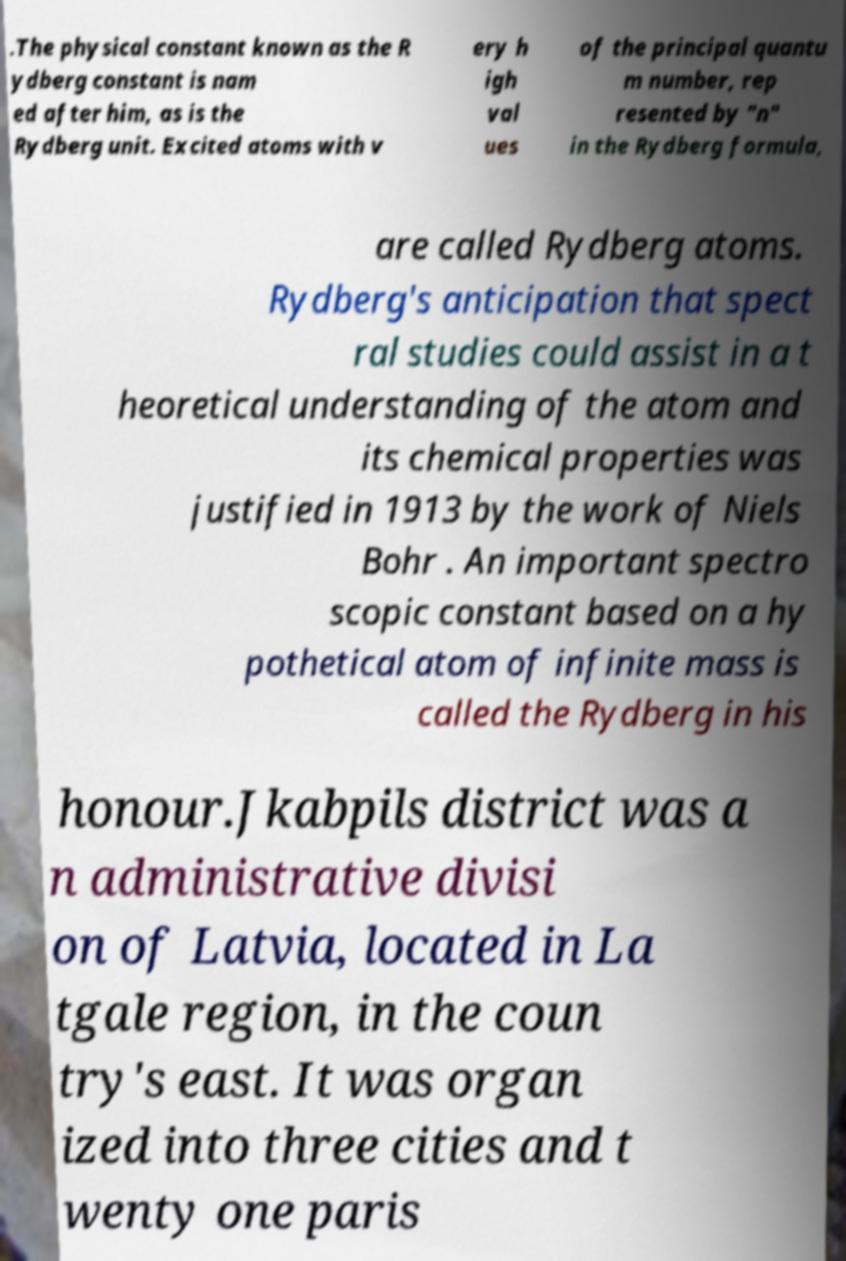Please identify and transcribe the text found in this image. .The physical constant known as the R ydberg constant is nam ed after him, as is the Rydberg unit. Excited atoms with v ery h igh val ues of the principal quantu m number, rep resented by "n" in the Rydberg formula, are called Rydberg atoms. Rydberg's anticipation that spect ral studies could assist in a t heoretical understanding of the atom and its chemical properties was justified in 1913 by the work of Niels Bohr . An important spectro scopic constant based on a hy pothetical atom of infinite mass is called the Rydberg in his honour.Jkabpils district was a n administrative divisi on of Latvia, located in La tgale region, in the coun try's east. It was organ ized into three cities and t wenty one paris 